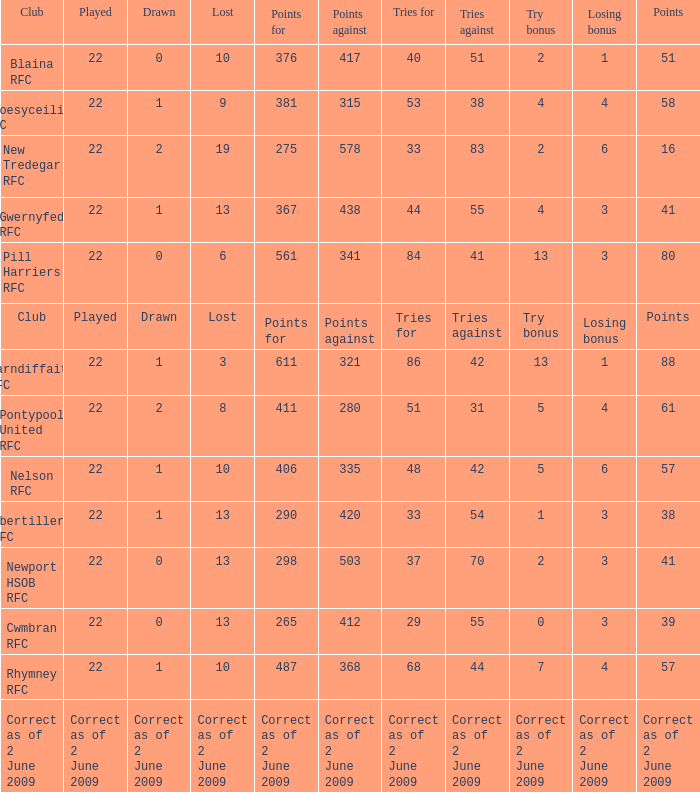How many tries against did the club with 1 drawn and 41 points have? 55.0. 